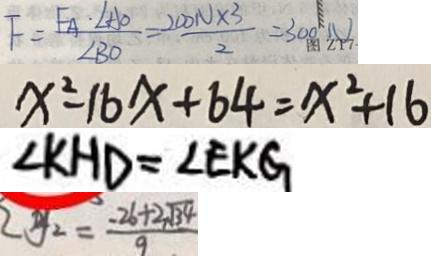<formula> <loc_0><loc_0><loc_500><loc_500>F = \frac { F _ { A } \cdot \angle A O } { \angle B O } = \frac { 2 0 0 N \times 3 } { 2 } = 3 0 0 N 
 x ^ { 2 } - 1 6 x + 6 4 = x ^ { 2 } + 1 6 
 \angle K H D = \angle E K G 
 y _ { 2 } = \frac { - 2 6 + 2 \sqrt { 3 4 } } { 9 }</formula> 